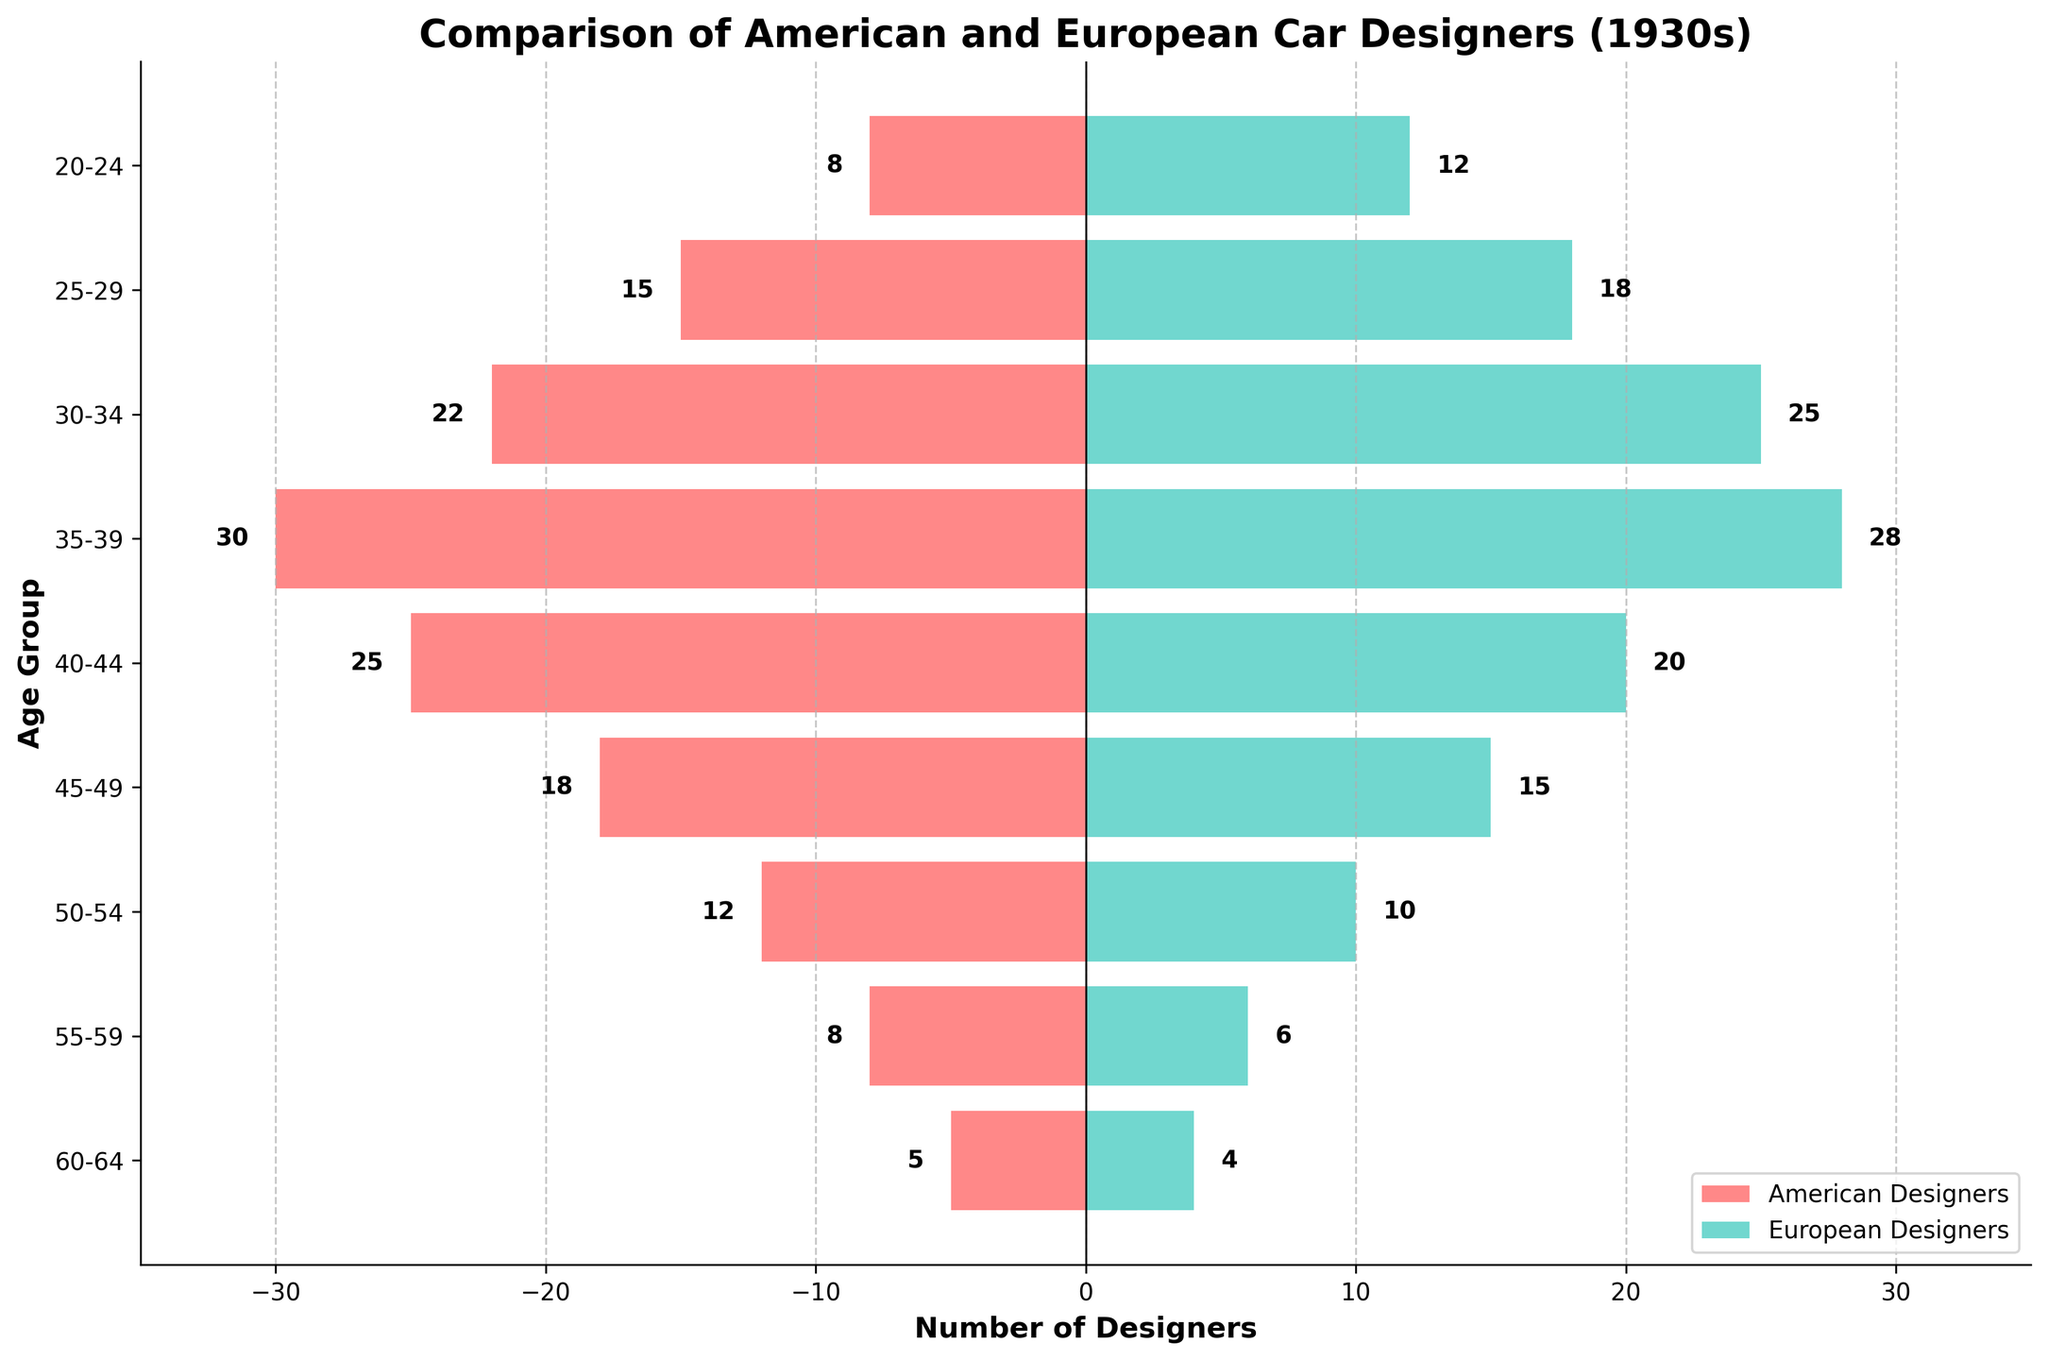What are the colors representing American and European car designers in the figure? The figure uses color to differentiate between American and European car designers. American designers are represented by a reddish color, while European designers are represented by a bluish-green color.
Answer: American: reddish, European: bluish-green What is the title of the figure? The title of the figure is located at the top of the plot. It indicates that the figure is about the comparison of American and European car designers in the 1930s.
Answer: Comparison of American and European Car Designers (1930s) How many age groups are shown in the figure? The figure displays the car designers across different age groups. Counting the number of categories along the vertical axis, there are nine age groups shown in the figure.
Answer: 9 What is the largest age group for American car designers? By looking at the lengths of the bars on the left side of the pyramid, the age group with the longest bar represents the largest group of American car designers. The 35-39 age group has the longest bar.
Answer: 35-39 How many American car designers are in the 25-29 and 30-34 age groups combined? To find the total number of American car designers in both age groups, sum the values for these groups. The numbers are 15 (25-29) and 22 (30-34). Adding these gives 15 + 22 = 37.
Answer: 37 Which age group has more European car designers, the 40-44 group or the 50-54 group? To determine this, compare the lengths of the bars on the right side of the pyramid for the 40-44 and 50-54 age groups. The 40-44 group has 20 designers, and the 50-54 group has 10 designers. Therefore, the 40-44 group has more designers.
Answer: 40-44 group What is the age group with the smallest number of European designers? By looking at the shortest bar lengths on the right side of the pyramid, the age group with the smallest number of European car designers is from 60-64 with 4 designers.
Answer: 60-64 How many more American designers are there in the 55-59 age group compared to the 20-24 age group? Find the difference between the number of American designers in the 55-59 and 20-24 age groups. The numbers are 8 (55-59) and 8 (20-24). The difference is 8 - 8 = 0.
Answer: 0 What is the total number of designers in the largest age group (35-39) across both regions? Sum the number of designers in the 35-39 age group for both Americans and Europeans. The values are 30 (American) and 28 (European). Adding these gives 30 + 28 = 58.
Answer: 58 Are there more American or European car designers in the 45-49 age group? To determine which region has more designers in the 45-49 age group, compare the values from the figure. There are 18 American designers and 15 European designers, so there are more American designers.
Answer: American designers 